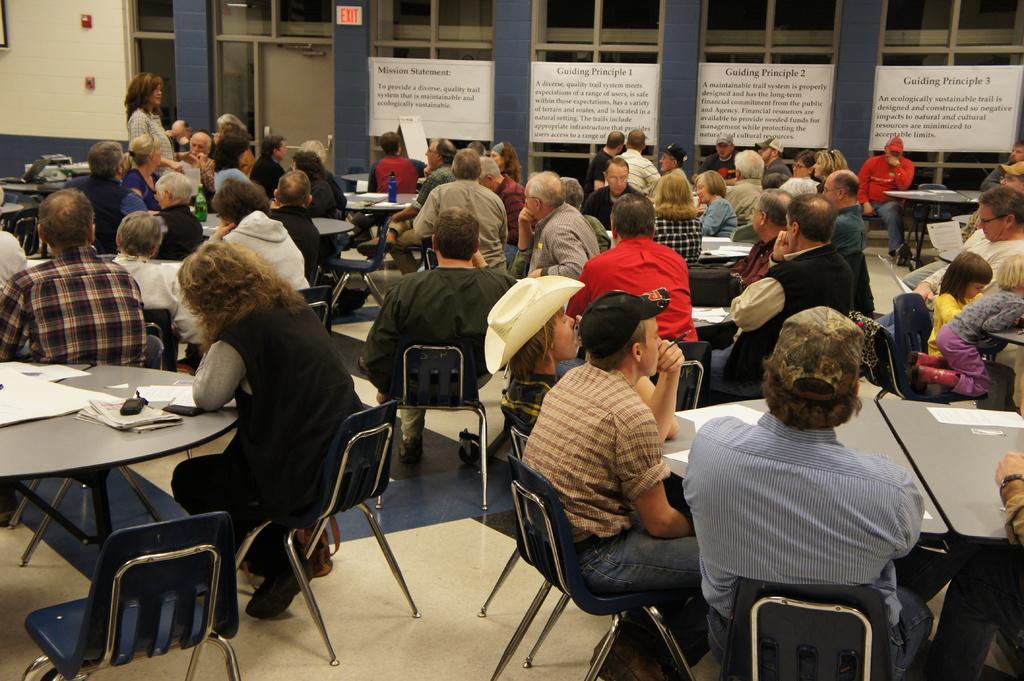In one or two sentences, can you explain what this image depicts? In this image there are group of people sitting on the chair in front of the table on which paper, bottles, laptop and soon kept. In the top left one woman is standing and speaking. The background walls are light yellow and blue in color. The pillars are blue in color. In the right boards are visible and windows are visible. This image is taken inside a hall. 